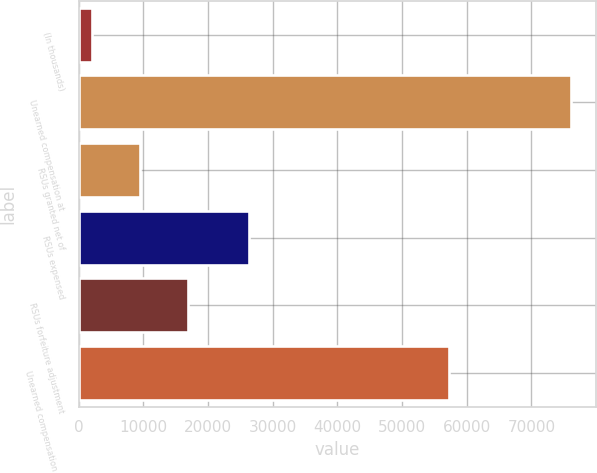<chart> <loc_0><loc_0><loc_500><loc_500><bar_chart><fcel>(In thousands)<fcel>Unearned compensation at<fcel>RSUs granted net of<fcel>RSUs expensed<fcel>RSUs forfeiture adjustment<fcel>Unearned compensation at end<nl><fcel>2011<fcel>76139<fcel>9423.8<fcel>26303<fcel>16836.6<fcel>57315<nl></chart> 